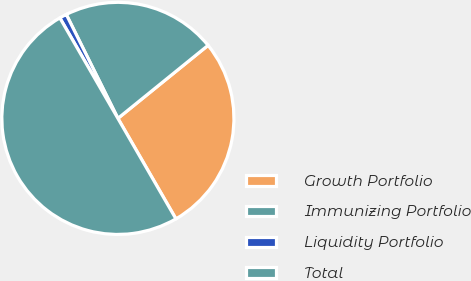Convert chart. <chart><loc_0><loc_0><loc_500><loc_500><pie_chart><fcel>Growth Portfolio<fcel>Immunizing Portfolio<fcel>Liquidity Portfolio<fcel>Total<nl><fcel>27.5%<fcel>21.5%<fcel>1.0%<fcel>50.0%<nl></chart> 